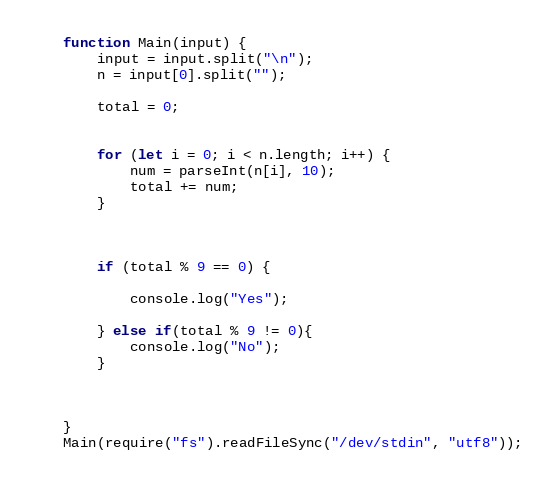<code> <loc_0><loc_0><loc_500><loc_500><_JavaScript_>function Main(input) {
    input = input.split("\n");
    n = input[0].split("");
    
    total = 0;

    
    for (let i = 0; i < n.length; i++) {
        num = parseInt(n[i], 10);
        total += num;        
    }



    if (total % 9 == 0) {

        console.log("Yes");
        
    } else if(total % 9 != 0){
        console.log("No");
    }



}
Main(require("fs").readFileSync("/dev/stdin", "utf8"));</code> 